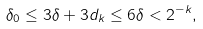Convert formula to latex. <formula><loc_0><loc_0><loc_500><loc_500>\delta _ { 0 } \leq 3 \delta + 3 d _ { k } \leq 6 \delta < 2 ^ { - k } ,</formula> 